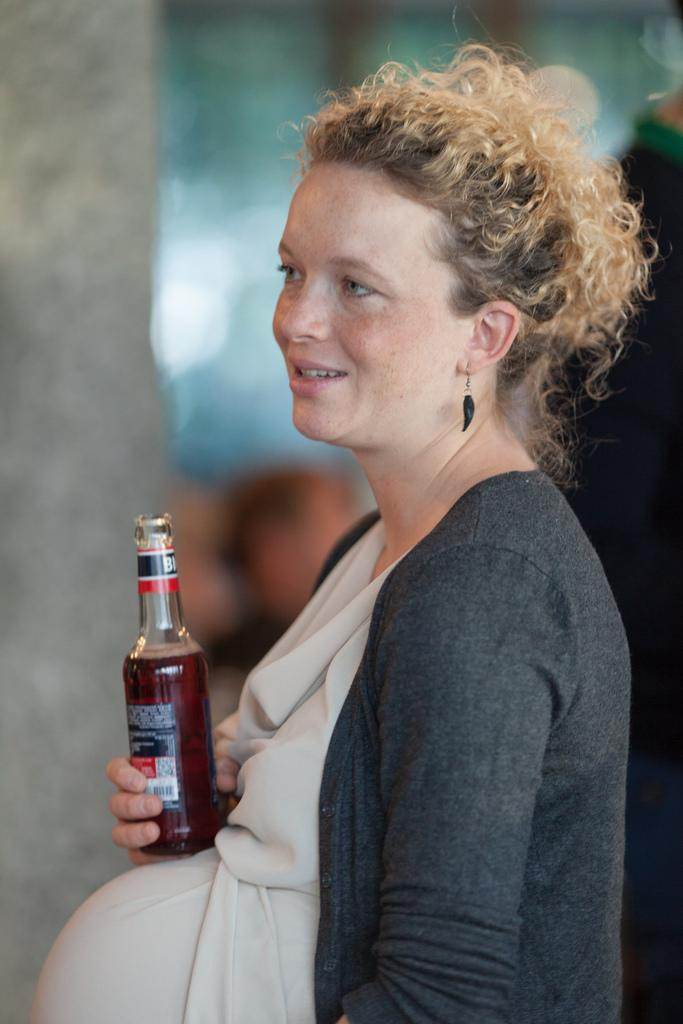What is the main subject of the image? The main subject of the image is a pregnant woman. What is the pregnant woman doing in the image? The pregnant woman is standing in the image. What object is the pregnant woman holding in her hand? The pregnant woman is holding an alcohol bottle in her hand. Can you see any fish swimming in the image? No, there are no fish present in the image. Is there a rainstorm happening in the image? No, there is no rainstorm depicted in the image. 